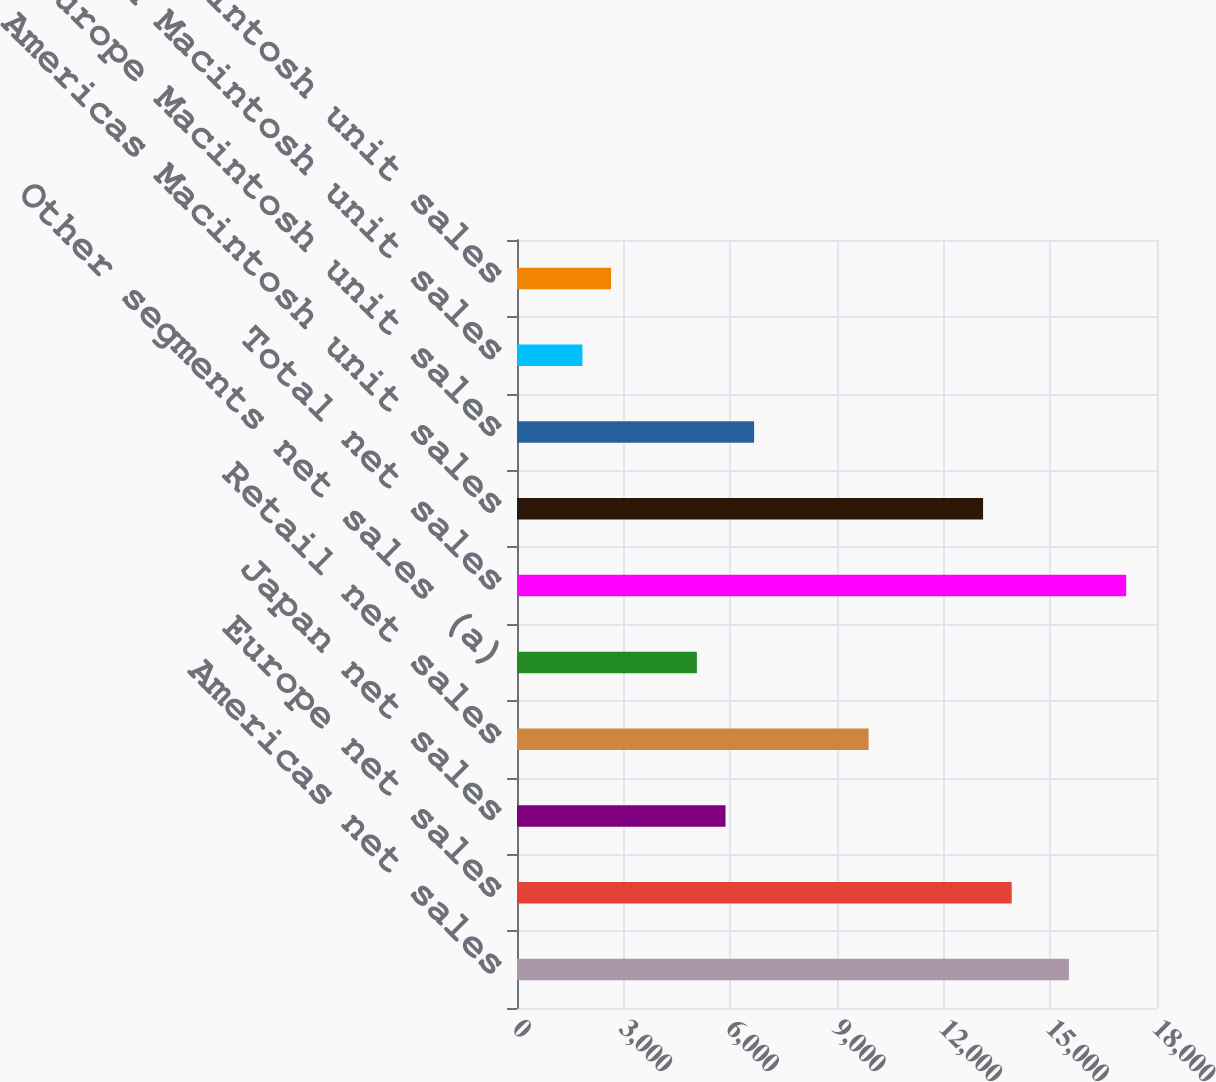Convert chart to OTSL. <chart><loc_0><loc_0><loc_500><loc_500><bar_chart><fcel>Americas net sales<fcel>Europe net sales<fcel>Japan net sales<fcel>Retail net sales<fcel>Other segments net sales (a)<fcel>Total net sales<fcel>Americas Macintosh unit sales<fcel>Europe Macintosh unit sales<fcel>Japan Macintosh unit sales<fcel>Retail Macintosh unit sales<nl><fcel>15523.1<fcel>13913.3<fcel>5864.3<fcel>9888.8<fcel>5059.4<fcel>17132.9<fcel>13108.4<fcel>6669.2<fcel>1839.8<fcel>2644.7<nl></chart> 